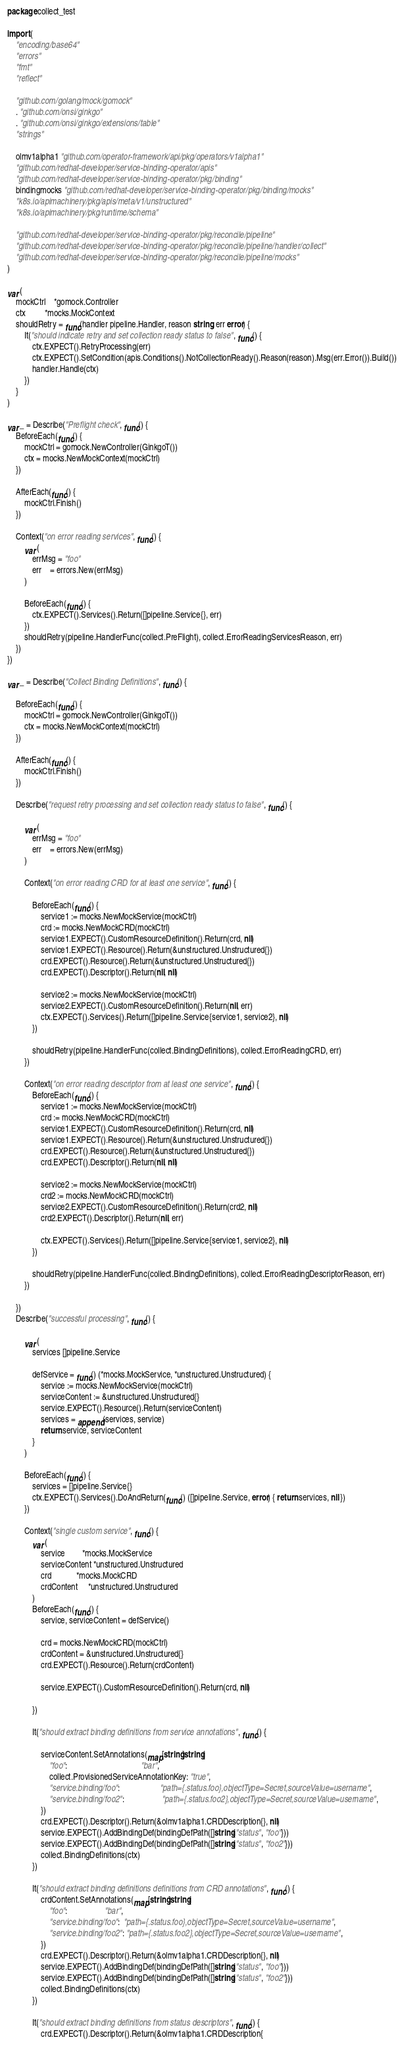Convert code to text. <code><loc_0><loc_0><loc_500><loc_500><_Go_>package collect_test

import (
	"encoding/base64"
	"errors"
	"fmt"
	"reflect"

	"github.com/golang/mock/gomock"
	. "github.com/onsi/ginkgo"
	. "github.com/onsi/ginkgo/extensions/table"
	"strings"

	olmv1alpha1 "github.com/operator-framework/api/pkg/operators/v1alpha1"
	"github.com/redhat-developer/service-binding-operator/apis"
	"github.com/redhat-developer/service-binding-operator/pkg/binding"
	bindingmocks "github.com/redhat-developer/service-binding-operator/pkg/binding/mocks"
	"k8s.io/apimachinery/pkg/apis/meta/v1/unstructured"
	"k8s.io/apimachinery/pkg/runtime/schema"

	"github.com/redhat-developer/service-binding-operator/pkg/reconcile/pipeline"
	"github.com/redhat-developer/service-binding-operator/pkg/reconcile/pipeline/handler/collect"
	"github.com/redhat-developer/service-binding-operator/pkg/reconcile/pipeline/mocks"
)

var (
	mockCtrl    *gomock.Controller
	ctx         *mocks.MockContext
	shouldRetry = func(handler pipeline.Handler, reason string, err error) {
		It("should indicate retry and set collection ready status to false", func() {
			ctx.EXPECT().RetryProcessing(err)
			ctx.EXPECT().SetCondition(apis.Conditions().NotCollectionReady().Reason(reason).Msg(err.Error()).Build())
			handler.Handle(ctx)
		})
	}
)

var _ = Describe("Preflight check", func() {
	BeforeEach(func() {
		mockCtrl = gomock.NewController(GinkgoT())
		ctx = mocks.NewMockContext(mockCtrl)
	})

	AfterEach(func() {
		mockCtrl.Finish()
	})

	Context("on error reading services", func() {
		var (
			errMsg = "foo"
			err    = errors.New(errMsg)
		)

		BeforeEach(func() {
			ctx.EXPECT().Services().Return([]pipeline.Service{}, err)
		})
		shouldRetry(pipeline.HandlerFunc(collect.PreFlight), collect.ErrorReadingServicesReason, err)
	})
})

var _ = Describe("Collect Binding Definitions", func() {

	BeforeEach(func() {
		mockCtrl = gomock.NewController(GinkgoT())
		ctx = mocks.NewMockContext(mockCtrl)
	})

	AfterEach(func() {
		mockCtrl.Finish()
	})

	Describe("request retry processing and set collection ready status to false", func() {

		var (
			errMsg = "foo"
			err    = errors.New(errMsg)
		)

		Context("on error reading CRD for at least one service", func() {

			BeforeEach(func() {
				service1 := mocks.NewMockService(mockCtrl)
				crd := mocks.NewMockCRD(mockCtrl)
				service1.EXPECT().CustomResourceDefinition().Return(crd, nil)
				service1.EXPECT().Resource().Return(&unstructured.Unstructured{})
				crd.EXPECT().Resource().Return(&unstructured.Unstructured{})
				crd.EXPECT().Descriptor().Return(nil, nil)

				service2 := mocks.NewMockService(mockCtrl)
				service2.EXPECT().CustomResourceDefinition().Return(nil, err)
				ctx.EXPECT().Services().Return([]pipeline.Service{service1, service2}, nil)
			})

			shouldRetry(pipeline.HandlerFunc(collect.BindingDefinitions), collect.ErrorReadingCRD, err)
		})

		Context("on error reading descriptor from at least one service", func() {
			BeforeEach(func() {
				service1 := mocks.NewMockService(mockCtrl)
				crd := mocks.NewMockCRD(mockCtrl)
				service1.EXPECT().CustomResourceDefinition().Return(crd, nil)
				service1.EXPECT().Resource().Return(&unstructured.Unstructured{})
				crd.EXPECT().Resource().Return(&unstructured.Unstructured{})
				crd.EXPECT().Descriptor().Return(nil, nil)

				service2 := mocks.NewMockService(mockCtrl)
				crd2 := mocks.NewMockCRD(mockCtrl)
				service2.EXPECT().CustomResourceDefinition().Return(crd2, nil)
				crd2.EXPECT().Descriptor().Return(nil, err)

				ctx.EXPECT().Services().Return([]pipeline.Service{service1, service2}, nil)
			})

			shouldRetry(pipeline.HandlerFunc(collect.BindingDefinitions), collect.ErrorReadingDescriptorReason, err)
		})

	})
	Describe("successful processing", func() {

		var (
			services []pipeline.Service

			defService = func() (*mocks.MockService, *unstructured.Unstructured) {
				service := mocks.NewMockService(mockCtrl)
				serviceContent := &unstructured.Unstructured{}
				service.EXPECT().Resource().Return(serviceContent)
				services = append(services, service)
				return service, serviceContent
			}
		)

		BeforeEach(func() {
			services = []pipeline.Service{}
			ctx.EXPECT().Services().DoAndReturn(func() ([]pipeline.Service, error) { return services, nil })
		})

		Context("single custom service", func() {
			var (
				service        *mocks.MockService
				serviceContent *unstructured.Unstructured
				crd            *mocks.MockCRD
				crdContent     *unstructured.Unstructured
			)
			BeforeEach(func() {
				service, serviceContent = defService()

				crd = mocks.NewMockCRD(mockCtrl)
				crdContent = &unstructured.Unstructured{}
				crd.EXPECT().Resource().Return(crdContent)

				service.EXPECT().CustomResourceDefinition().Return(crd, nil)

			})

			It("should extract binding definitions from service annotations", func() {

				serviceContent.SetAnnotations(map[string]string{
					"foo":                                   "bar",
					collect.ProvisionedServiceAnnotationKey: "true",
					"service.binding/foo":                   "path={.status.foo},objectType=Secret,sourceValue=username",
					"service.binding/foo2":                  "path={.status.foo2},objectType=Secret,sourceValue=username",
				})
				crd.EXPECT().Descriptor().Return(&olmv1alpha1.CRDDescription{}, nil)
				service.EXPECT().AddBindingDef(bindingDefPath([]string{"status", "foo"}))
				service.EXPECT().AddBindingDef(bindingDefPath([]string{"status", "foo2"}))
				collect.BindingDefinitions(ctx)
			})

			It("should extract binding definitions definitions from CRD annotations", func() {
				crdContent.SetAnnotations(map[string]string{
					"foo":                  "bar",
					"service.binding/foo":  "path={.status.foo},objectType=Secret,sourceValue=username",
					"service.binding/foo2": "path={.status.foo2},objectType=Secret,sourceValue=username",
				})
				crd.EXPECT().Descriptor().Return(&olmv1alpha1.CRDDescription{}, nil)
				service.EXPECT().AddBindingDef(bindingDefPath([]string{"status", "foo"}))
				service.EXPECT().AddBindingDef(bindingDefPath([]string{"status", "foo2"}))
				collect.BindingDefinitions(ctx)
			})

			It("should extract binding definitions from status descriptors", func() {
				crd.EXPECT().Descriptor().Return(&olmv1alpha1.CRDDescription{</code> 